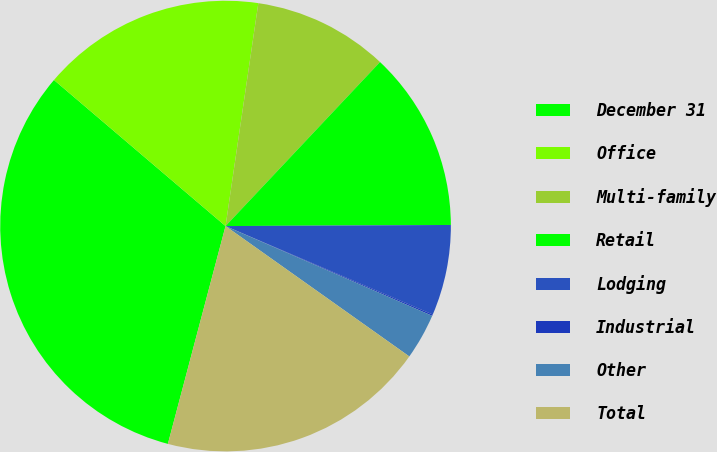Convert chart to OTSL. <chart><loc_0><loc_0><loc_500><loc_500><pie_chart><fcel>December 31<fcel>Office<fcel>Multi-family<fcel>Retail<fcel>Lodging<fcel>Industrial<fcel>Other<fcel>Total<nl><fcel>32.11%<fcel>16.1%<fcel>9.7%<fcel>12.9%<fcel>6.5%<fcel>0.1%<fcel>3.3%<fcel>19.3%<nl></chart> 